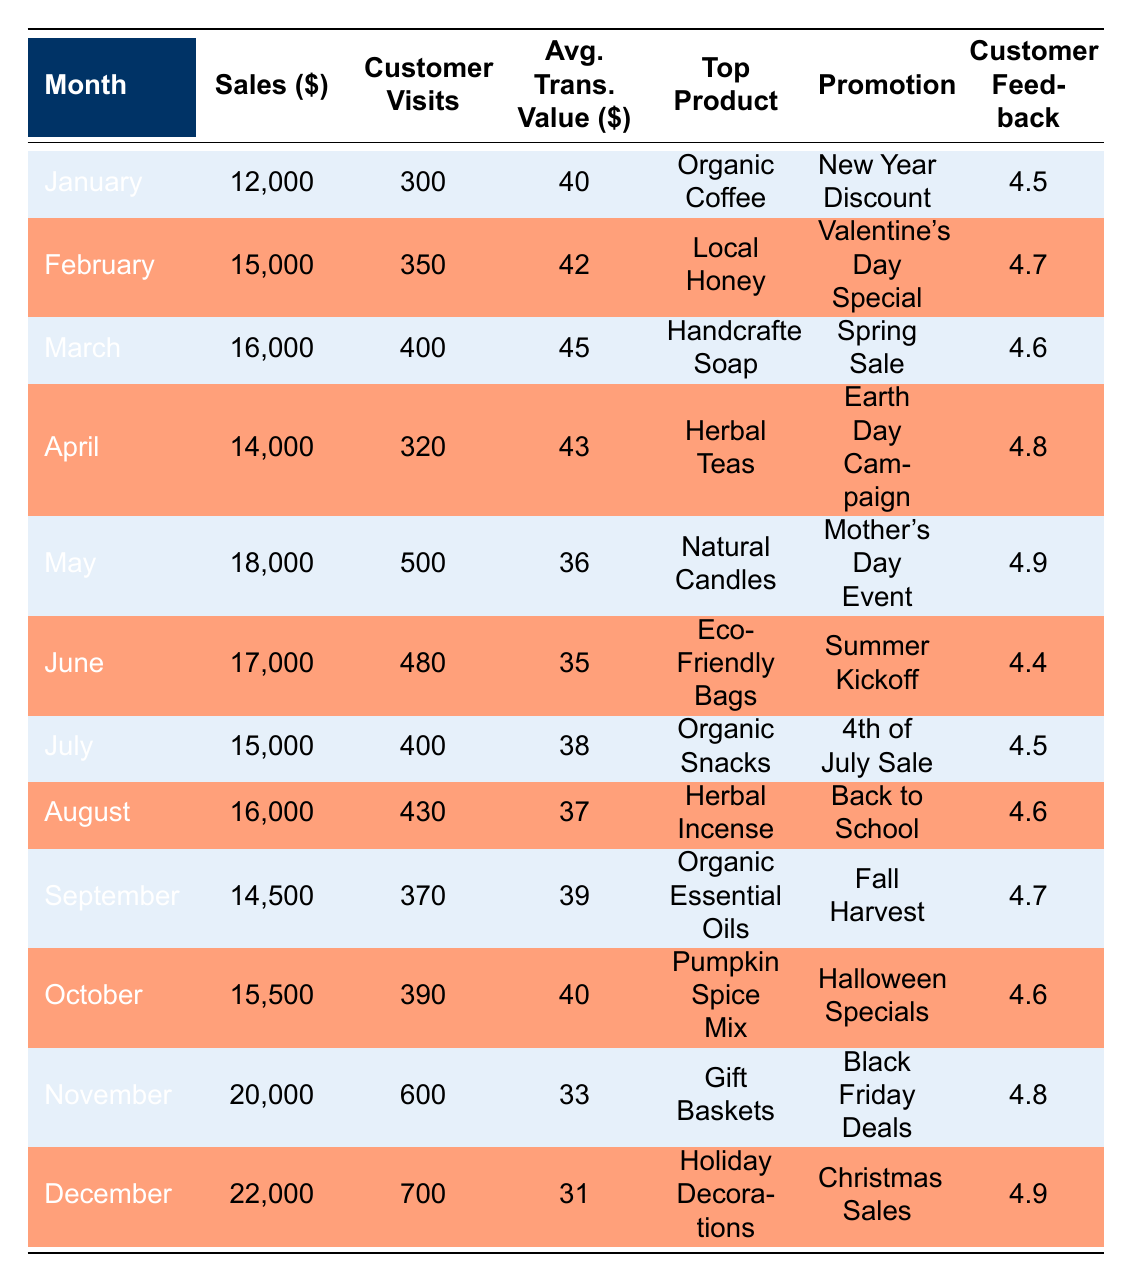What was the top product sold in December? According to the table, December's top product is "Holiday Decorations."
Answer: Holiday Decorations Which month had the highest customer feedback score? By examining the Customer Feedback column, both May and December have the highest score of 4.9, but May comes before December.
Answer: May and December What is the average transaction value in August? From the table, the Average Transaction Value in August is 37. There is no calculation needed as this value is directly listed.
Answer: 37 What were the sales for November, and how do they compare to October? The sales for November are 20,000, while October’s sales are 15,500. The difference is 20,000 - 15,500 = 4,500, meaning November's sales were higher.
Answer: 20,000; November's sales were 4,500 higher than October's Is the customer visit count in June higher than in January? The Customer Visits in January are 300, while in June they are 480. Since 480 is greater than 300, the statement is true.
Answer: Yes What is the total sales for the first half of the year (January to June)? To calculate this, we sum the sales for each month from January to June: 12,000 + 15,000 + 16,000 + 14,000 + 18,000 + 17,000 = 92,000.
Answer: 92,000 Was there a month in which the average transaction value was lower than 35? By checking the Average Transaction Value column, June has a value of 35. Meanwhile, May's value was 36, so there isn't a month below 35.
Answer: No How much did sales increase from March to May? The sales in March are 16,000, and in May, they are 18,000. The increase is calculated as follows: 18,000 - 16,000 = 2,000.
Answer: 2,000 Which month had the highest number of customer visits and what was that number? Looking through the Customer Visits column, December has the highest number at 700.
Answer: 700 